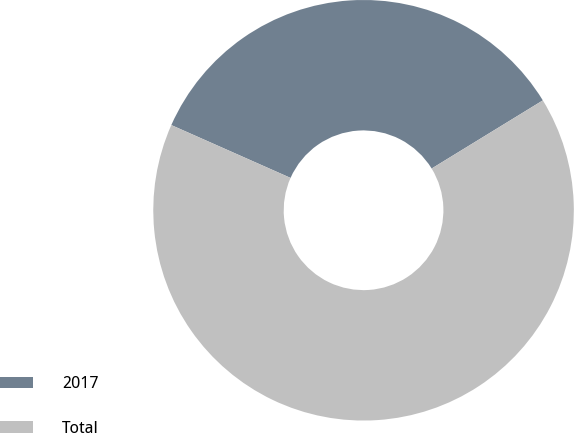Convert chart. <chart><loc_0><loc_0><loc_500><loc_500><pie_chart><fcel>2017<fcel>Total<nl><fcel>34.61%<fcel>65.39%<nl></chart> 